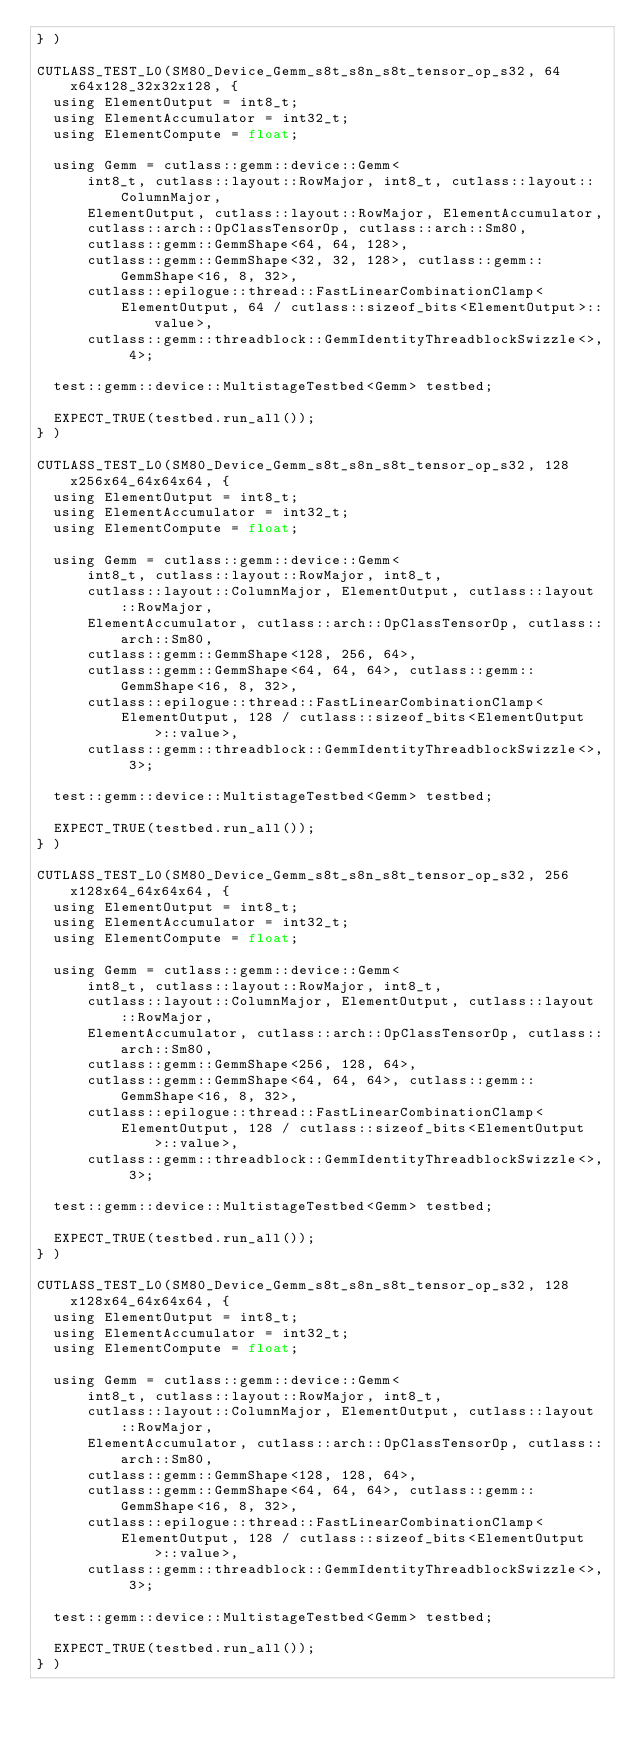Convert code to text. <code><loc_0><loc_0><loc_500><loc_500><_Cuda_>} )

CUTLASS_TEST_L0(SM80_Device_Gemm_s8t_s8n_s8t_tensor_op_s32, 64x64x128_32x32x128, {
  using ElementOutput = int8_t;
  using ElementAccumulator = int32_t;
  using ElementCompute = float;

  using Gemm = cutlass::gemm::device::Gemm<
      int8_t, cutlass::layout::RowMajor, int8_t, cutlass::layout::ColumnMajor,
      ElementOutput, cutlass::layout::RowMajor, ElementAccumulator,
      cutlass::arch::OpClassTensorOp, cutlass::arch::Sm80,
      cutlass::gemm::GemmShape<64, 64, 128>,
      cutlass::gemm::GemmShape<32, 32, 128>, cutlass::gemm::GemmShape<16, 8, 32>,
      cutlass::epilogue::thread::FastLinearCombinationClamp<
          ElementOutput, 64 / cutlass::sizeof_bits<ElementOutput>::value>,
      cutlass::gemm::threadblock::GemmIdentityThreadblockSwizzle<>, 4>;

  test::gemm::device::MultistageTestbed<Gemm> testbed;

  EXPECT_TRUE(testbed.run_all());
} )

CUTLASS_TEST_L0(SM80_Device_Gemm_s8t_s8n_s8t_tensor_op_s32, 128x256x64_64x64x64, {
  using ElementOutput = int8_t;
  using ElementAccumulator = int32_t;
  using ElementCompute = float;

  using Gemm = cutlass::gemm::device::Gemm<
      int8_t, cutlass::layout::RowMajor, int8_t,
      cutlass::layout::ColumnMajor, ElementOutput, cutlass::layout::RowMajor,
      ElementAccumulator, cutlass::arch::OpClassTensorOp, cutlass::arch::Sm80,
      cutlass::gemm::GemmShape<128, 256, 64>,
      cutlass::gemm::GemmShape<64, 64, 64>, cutlass::gemm::GemmShape<16, 8, 32>,
      cutlass::epilogue::thread::FastLinearCombinationClamp<
          ElementOutput, 128 / cutlass::sizeof_bits<ElementOutput>::value>,
      cutlass::gemm::threadblock::GemmIdentityThreadblockSwizzle<>, 3>;

  test::gemm::device::MultistageTestbed<Gemm> testbed;

  EXPECT_TRUE(testbed.run_all());
} )

CUTLASS_TEST_L0(SM80_Device_Gemm_s8t_s8n_s8t_tensor_op_s32, 256x128x64_64x64x64, {
  using ElementOutput = int8_t;
  using ElementAccumulator = int32_t;
  using ElementCompute = float;

  using Gemm = cutlass::gemm::device::Gemm<
      int8_t, cutlass::layout::RowMajor, int8_t,
      cutlass::layout::ColumnMajor, ElementOutput, cutlass::layout::RowMajor,
      ElementAccumulator, cutlass::arch::OpClassTensorOp, cutlass::arch::Sm80,
      cutlass::gemm::GemmShape<256, 128, 64>,
      cutlass::gemm::GemmShape<64, 64, 64>, cutlass::gemm::GemmShape<16, 8, 32>,
      cutlass::epilogue::thread::FastLinearCombinationClamp<
          ElementOutput, 128 / cutlass::sizeof_bits<ElementOutput>::value>,
      cutlass::gemm::threadblock::GemmIdentityThreadblockSwizzle<>, 3>;

  test::gemm::device::MultistageTestbed<Gemm> testbed;

  EXPECT_TRUE(testbed.run_all());
} )

CUTLASS_TEST_L0(SM80_Device_Gemm_s8t_s8n_s8t_tensor_op_s32, 128x128x64_64x64x64, {
  using ElementOutput = int8_t;
  using ElementAccumulator = int32_t;
  using ElementCompute = float;

  using Gemm = cutlass::gemm::device::Gemm<
      int8_t, cutlass::layout::RowMajor, int8_t,
      cutlass::layout::ColumnMajor, ElementOutput, cutlass::layout::RowMajor,
      ElementAccumulator, cutlass::arch::OpClassTensorOp, cutlass::arch::Sm80,
      cutlass::gemm::GemmShape<128, 128, 64>,
      cutlass::gemm::GemmShape<64, 64, 64>, cutlass::gemm::GemmShape<16, 8, 32>,
      cutlass::epilogue::thread::FastLinearCombinationClamp<
          ElementOutput, 128 / cutlass::sizeof_bits<ElementOutput>::value>,
      cutlass::gemm::threadblock::GemmIdentityThreadblockSwizzle<>, 3>;

  test::gemm::device::MultistageTestbed<Gemm> testbed;

  EXPECT_TRUE(testbed.run_all());
} )
</code> 